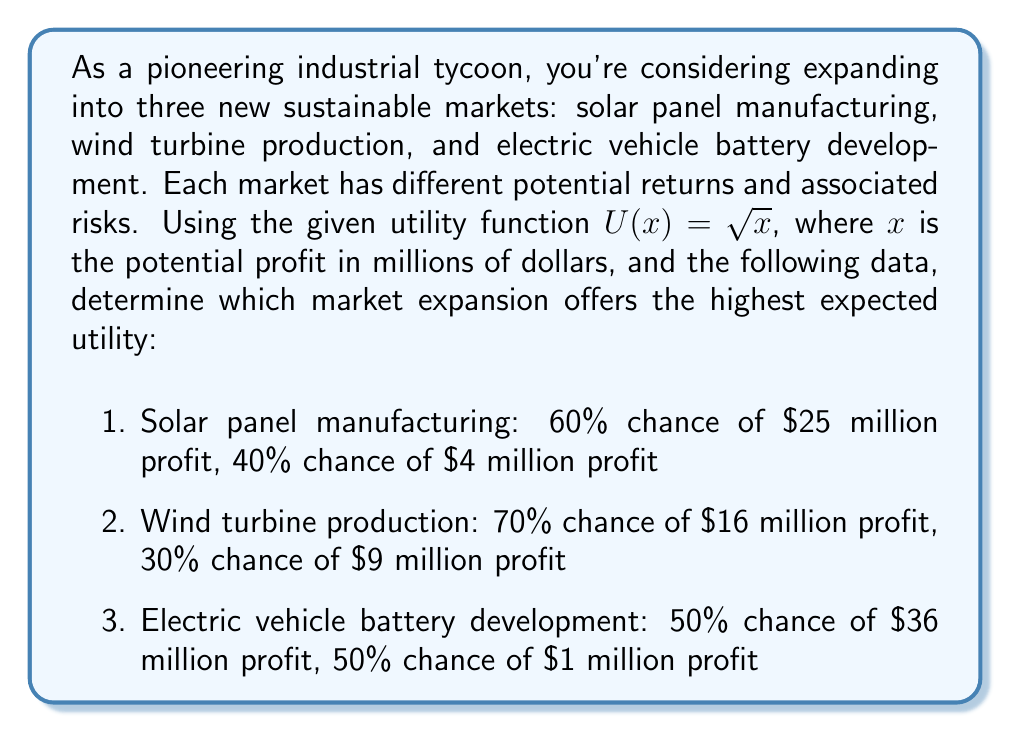What is the answer to this math problem? To solve this problem, we need to calculate the expected utility for each market expansion option using the given utility function and probability data. The expected utility is the sum of the utilities of each outcome multiplied by their respective probabilities.

1. Solar panel manufacturing:
   Expected Utility = $0.60 \cdot U(25) + 0.40 \cdot U(4)$
   $= 0.60 \cdot \sqrt{25} + 0.40 \cdot \sqrt{4}$
   $= 0.60 \cdot 5 + 0.40 \cdot 2$
   $= 3 + 0.8 = 3.8$

2. Wind turbine production:
   Expected Utility = $0.70 \cdot U(16) + 0.30 \cdot U(9)$
   $= 0.70 \cdot \sqrt{16} + 0.30 \cdot \sqrt{9}$
   $= 0.70 \cdot 4 + 0.30 \cdot 3$
   $= 2.8 + 0.9 = 3.7$

3. Electric vehicle battery development:
   Expected Utility = $0.50 \cdot U(36) + 0.50 \cdot U(1)$
   $= 0.50 \cdot \sqrt{36} + 0.50 \cdot \sqrt{1}$
   $= 0.50 \cdot 6 + 0.50 \cdot 1$
   $= 3 + 0.5 = 3.5$

Comparing the expected utilities:
Solar panel manufacturing: 3.8
Wind turbine production: 3.7
Electric vehicle battery development: 3.5

The highest expected utility is associated with solar panel manufacturing at 3.8.
Answer: The market expansion that offers the highest expected utility is solar panel manufacturing, with an expected utility of 3.8. 